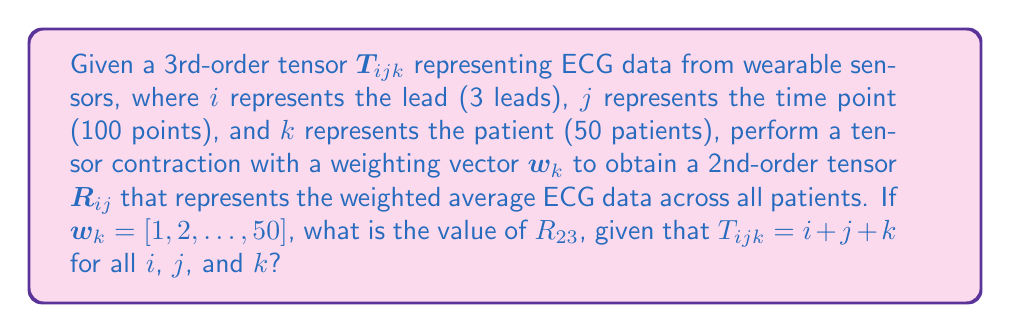Can you solve this math problem? Let's approach this step-by-step:

1) The tensor contraction we need to perform is:

   $$R_{ij} = \sum_{k=1}^{50} T_{ijk} w_k$$

2) We're given that $T_{ijk} = i + j + k$ for all $i$, $j$, and $k$.

3) We're also given that $w_k = [1, 2, ..., 50]$, which means $w_k = k$.

4) Substituting these into our contraction equation:

   $$R_{ij} = \sum_{k=1}^{50} (i + j + k) k$$

5) We can separate this sum:

   $$R_{ij} = i\sum_{k=1}^{50} k + j\sum_{k=1}^{50} k + \sum_{k=1}^{50} k^2$$

6) Now, let's recall some useful summation formulas:
   
   $$\sum_{k=1}^{n} k = \frac{n(n+1)}{2}$$
   $$\sum_{k=1}^{n} k^2 = \frac{n(n+1)(2n+1)}{6}$$

7) Applying these formulas with $n = 50$:

   $$R_{ij} = i \cdot \frac{50 \cdot 51}{2} + j \cdot \frac{50 \cdot 51}{2} + \frac{50 \cdot 51 \cdot 101}{6}$$

8) Simplifying:

   $$R_{ij} = 1275i + 1275j + 42500$$

9) We're asked to find $R_{23}$, so let's substitute $i=2$ and $j=3$:

   $$R_{23} = 1275 \cdot 2 + 1275 \cdot 3 + 42500$$
   $$R_{23} = 2550 + 3825 + 42500$$
   $$R_{23} = 48875$$

Therefore, the value of $R_{23}$ is 48875.
Answer: 48875 